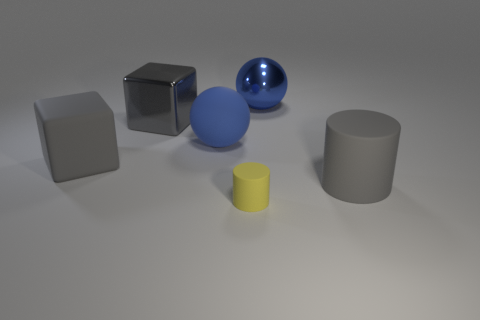Add 1 purple metallic cylinders. How many objects exist? 7 Subtract all balls. How many objects are left? 4 Subtract 0 green blocks. How many objects are left? 6 Subtract all yellow matte objects. Subtract all gray metallic things. How many objects are left? 4 Add 1 big matte spheres. How many big matte spheres are left? 2 Add 4 big spheres. How many big spheres exist? 6 